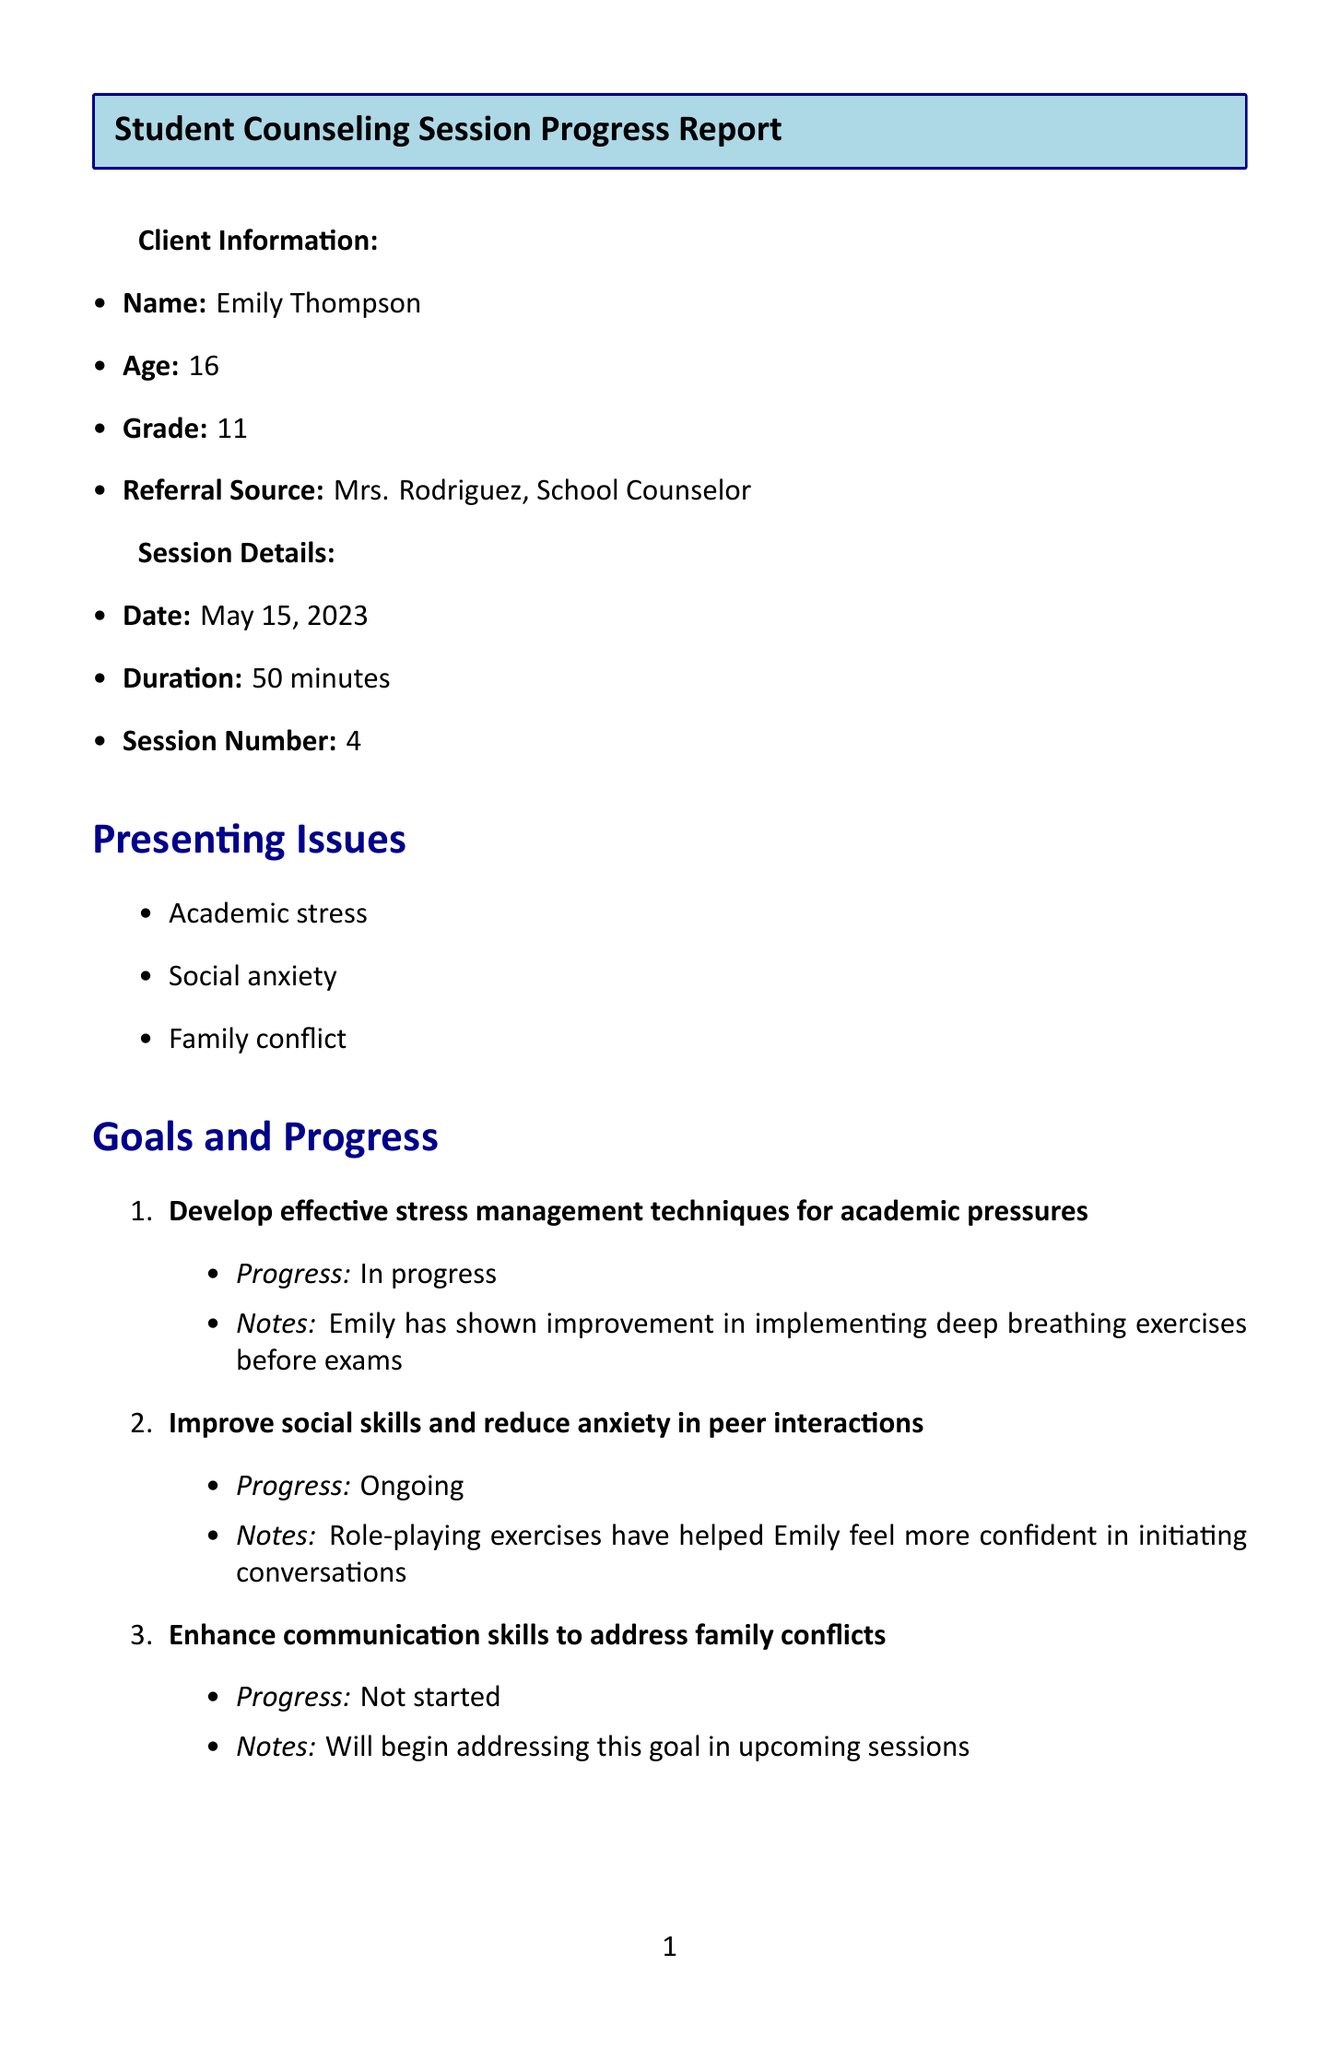What is the client's name? The client's name is mentioned at the beginning of the document in the Client Information section.
Answer: Emily Thompson What is the age of the client? The age of the client is included in the Client Information section of the document.
Answer: 16 What is the date of the counseling session? The date of the counseling session is specified in the Session Details section of the document.
Answer: May 15, 2023 How many goals are listed in the report? The number of goals can be derived from the Goals and Progress section, where each goal is enumerated.
Answer: 3 Which intervention has high effectiveness? The effectiveness of each intervention is described in the Interventions section, allowing for identification of those rated high.
Answer: Mindfulness exercises and Psychoeducation What area showed slight improvement? The document notes improvements in various areas; slight improvement is specifically mentioned in the Outcomes section.
Answer: Academic performance What is the main goal regarding communication? The main goal regarding communication can be found in the Goals and Progress section, focusing on addressing conflicts.
Answer: Enhance communication skills to address family conflicts What recommendations are made for the next session? The Recommendations for Next Session section provides specific suggestions for future counseling sessions.
Answer: Continue practicing CBT techniques for academic stress Who is the therapist? The therapist's information is located at the end of the document, indicating the individual responsible for the counseling.
Answer: Dr. Sarah Martinez 